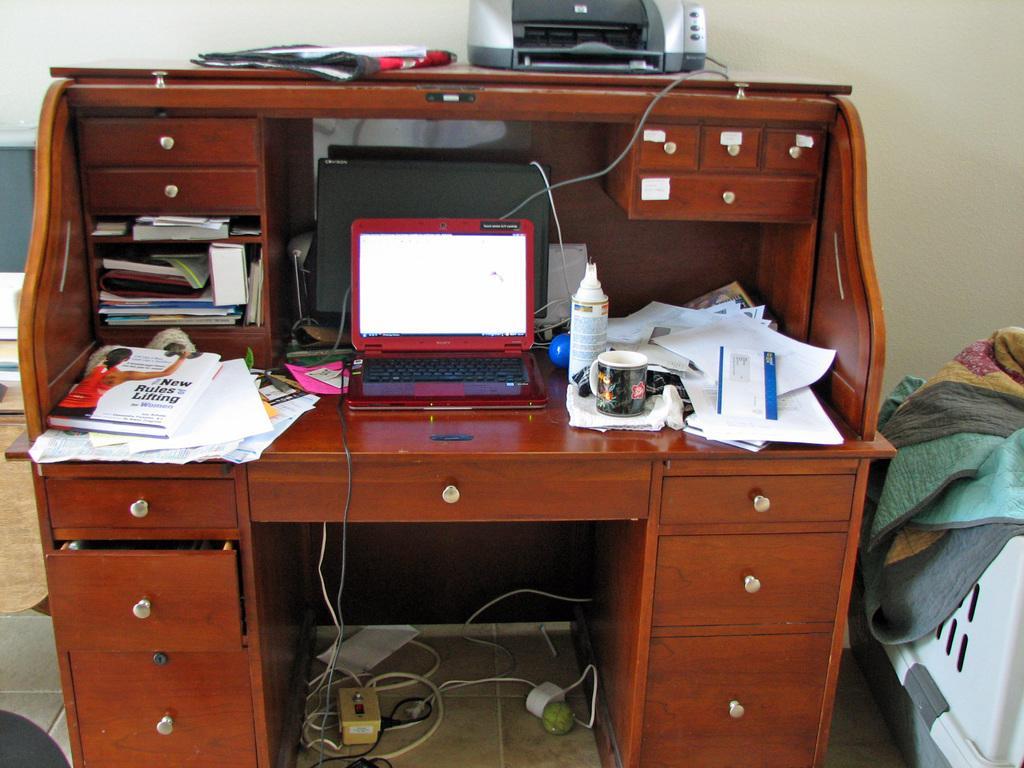How would you summarize this image in a sentence or two? It is Inside a room there is a big computer table with lot of draws, on the table to the left side there are some papers and books in between the laptop and monitor, to the right side there is a cup, a bottle and other papers above the table there is a printer, in the background there is a wall. 